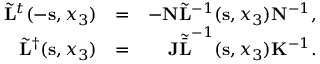<formula> <loc_0><loc_0><loc_500><loc_500>\begin{array} { r l r } { \tilde { L } ^ { t } ( - { s } , x _ { 3 } ) } & { = } & { - { N } \tilde { L } ^ { - 1 } ( { s } , x _ { 3 } ) { N } ^ { - 1 } , } \\ { \tilde { L } ^ { \dagger } ( { s } , x _ { 3 } ) } & { = } & { { J } { \tilde { \bar { L } } } ^ { - 1 } ( { s } , x _ { 3 } ) { K } ^ { - 1 } . } \end{array}</formula> 